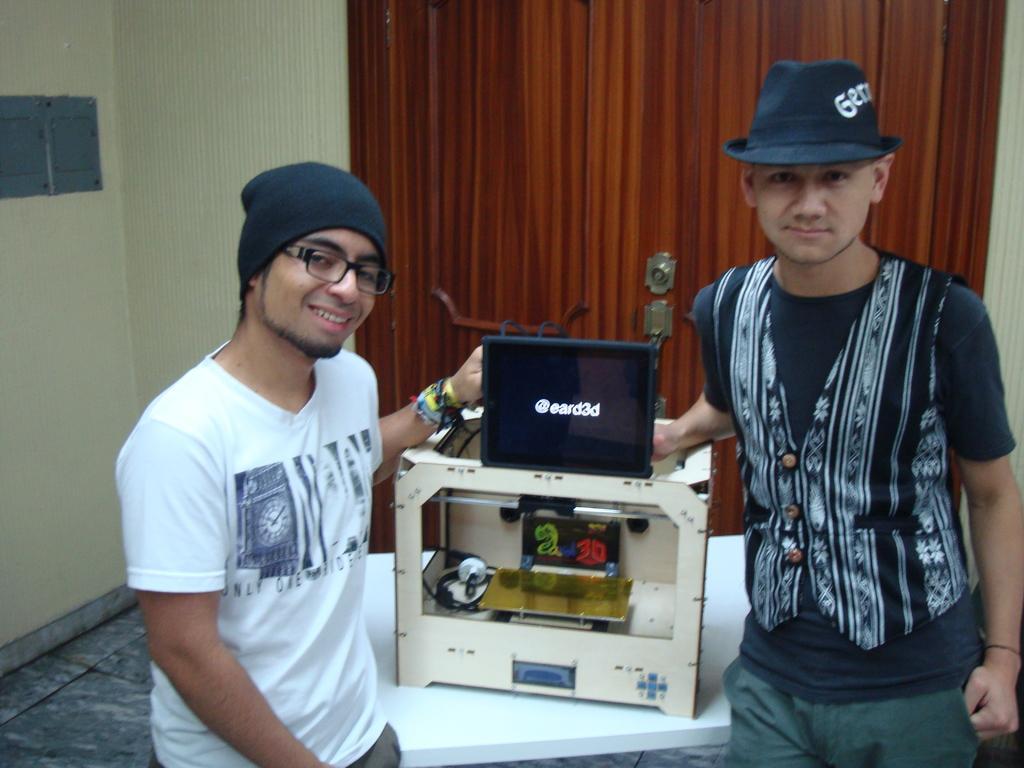Could you give a brief overview of what you see in this image? In this image I can see a person wearing white t shirt and black cap and another person wearing black and white dress are standing. I can see a white colored table and on it I can see an object which is gold, white, cream and black in color. In the background I can see the wall and the brown colored curtain. 